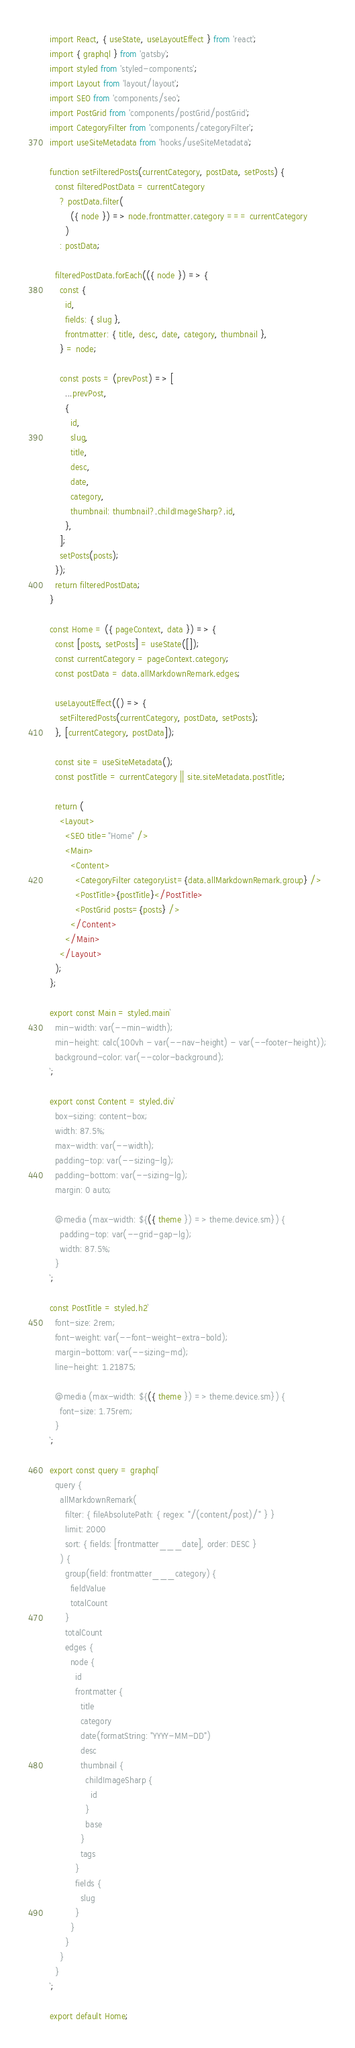Convert code to text. <code><loc_0><loc_0><loc_500><loc_500><_JavaScript_>import React, { useState, useLayoutEffect } from 'react';
import { graphql } from 'gatsby';
import styled from 'styled-components';
import Layout from 'layout/layout';
import SEO from 'components/seo';
import PostGrid from 'components/postGrid/postGrid';
import CategoryFilter from 'components/categoryFilter';
import useSiteMetadata from 'hooks/useSiteMetadata';

function setFilteredPosts(currentCategory, postData, setPosts) {
  const filteredPostData = currentCategory
    ? postData.filter(
        ({ node }) => node.frontmatter.category === currentCategory
      )
    : postData;

  filteredPostData.forEach(({ node }) => {
    const {
      id,
      fields: { slug },
      frontmatter: { title, desc, date, category, thumbnail },
    } = node;

    const posts = (prevPost) => [
      ...prevPost,
      {
        id,
        slug,
        title,
        desc,
        date,
        category,
        thumbnail: thumbnail?.childImageSharp?.id,
      },
    ];
    setPosts(posts);
  });
  return filteredPostData;
}

const Home = ({ pageContext, data }) => {
  const [posts, setPosts] = useState([]);
  const currentCategory = pageContext.category;
  const postData = data.allMarkdownRemark.edges;

  useLayoutEffect(() => {
    setFilteredPosts(currentCategory, postData, setPosts);
  }, [currentCategory, postData]);

  const site = useSiteMetadata();
  const postTitle = currentCategory || site.siteMetadata.postTitle;

  return (
    <Layout>
      <SEO title="Home" />
      <Main>
        <Content>
          <CategoryFilter categoryList={data.allMarkdownRemark.group} />
          <PostTitle>{postTitle}</PostTitle>
          <PostGrid posts={posts} />
        </Content>
      </Main>
    </Layout>
  );
};

export const Main = styled.main`
  min-width: var(--min-width);
  min-height: calc(100vh - var(--nav-height) - var(--footer-height));
  background-color: var(--color-background);
`;

export const Content = styled.div`
  box-sizing: content-box;
  width: 87.5%;
  max-width: var(--width);
  padding-top: var(--sizing-lg);
  padding-bottom: var(--sizing-lg);
  margin: 0 auto;

  @media (max-width: ${({ theme }) => theme.device.sm}) {
    padding-top: var(--grid-gap-lg);
    width: 87.5%;
  }
`;

const PostTitle = styled.h2`
  font-size: 2rem;
  font-weight: var(--font-weight-extra-bold);
  margin-bottom: var(--sizing-md);
  line-height: 1.21875;

  @media (max-width: ${({ theme }) => theme.device.sm}) {
    font-size: 1.75rem;
  }
`;

export const query = graphql`
  query {
    allMarkdownRemark(
      filter: { fileAbsolutePath: { regex: "/(content/post)/" } }
      limit: 2000
      sort: { fields: [frontmatter___date], order: DESC }
    ) {
      group(field: frontmatter___category) {
        fieldValue
        totalCount
      }
      totalCount
      edges {
        node {
          id
          frontmatter {
            title
            category
            date(formatString: "YYYY-MM-DD")
            desc
            thumbnail {
              childImageSharp {
                id
              }
              base
            }
            tags
          }
          fields {
            slug
          }
        }
      }
    }
  }
`;

export default Home;
</code> 